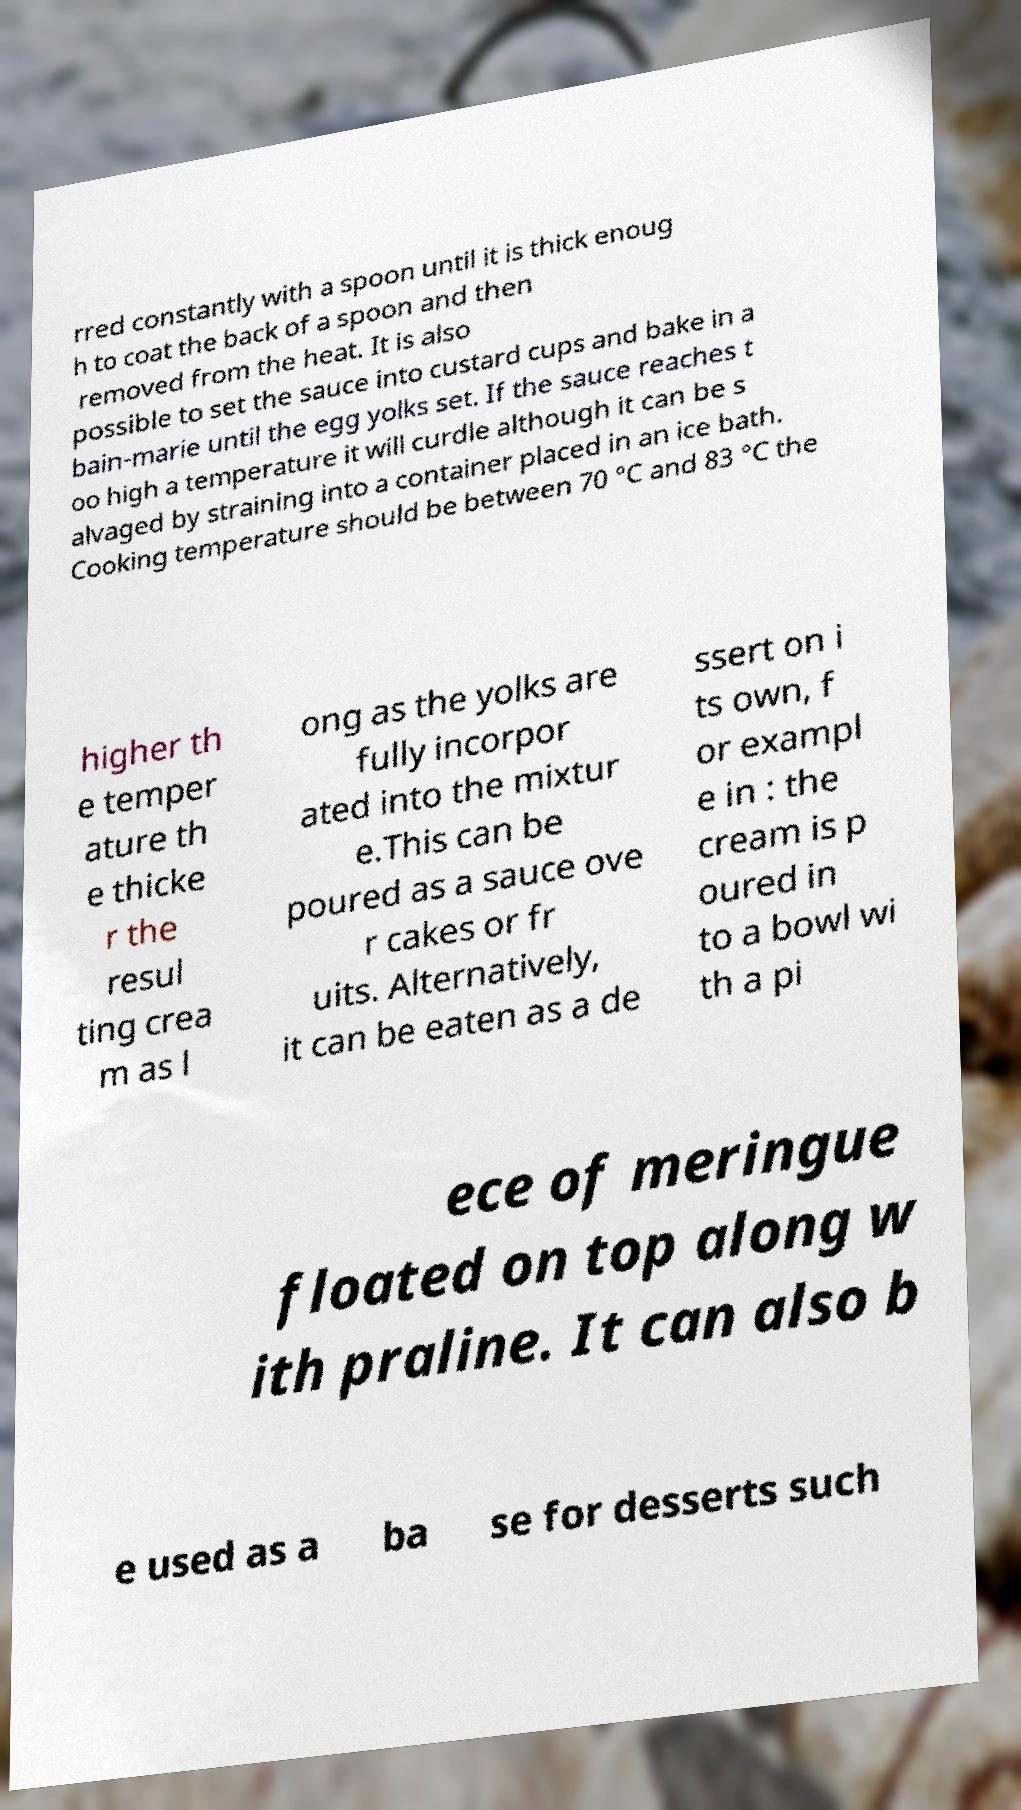Can you read and provide the text displayed in the image?This photo seems to have some interesting text. Can you extract and type it out for me? rred constantly with a spoon until it is thick enoug h to coat the back of a spoon and then removed from the heat. It is also possible to set the sauce into custard cups and bake in a bain-marie until the egg yolks set. If the sauce reaches t oo high a temperature it will curdle although it can be s alvaged by straining into a container placed in an ice bath. Cooking temperature should be between 70 °C and 83 °C the higher th e temper ature th e thicke r the resul ting crea m as l ong as the yolks are fully incorpor ated into the mixtur e.This can be poured as a sauce ove r cakes or fr uits. Alternatively, it can be eaten as a de ssert on i ts own, f or exampl e in : the cream is p oured in to a bowl wi th a pi ece of meringue floated on top along w ith praline. It can also b e used as a ba se for desserts such 